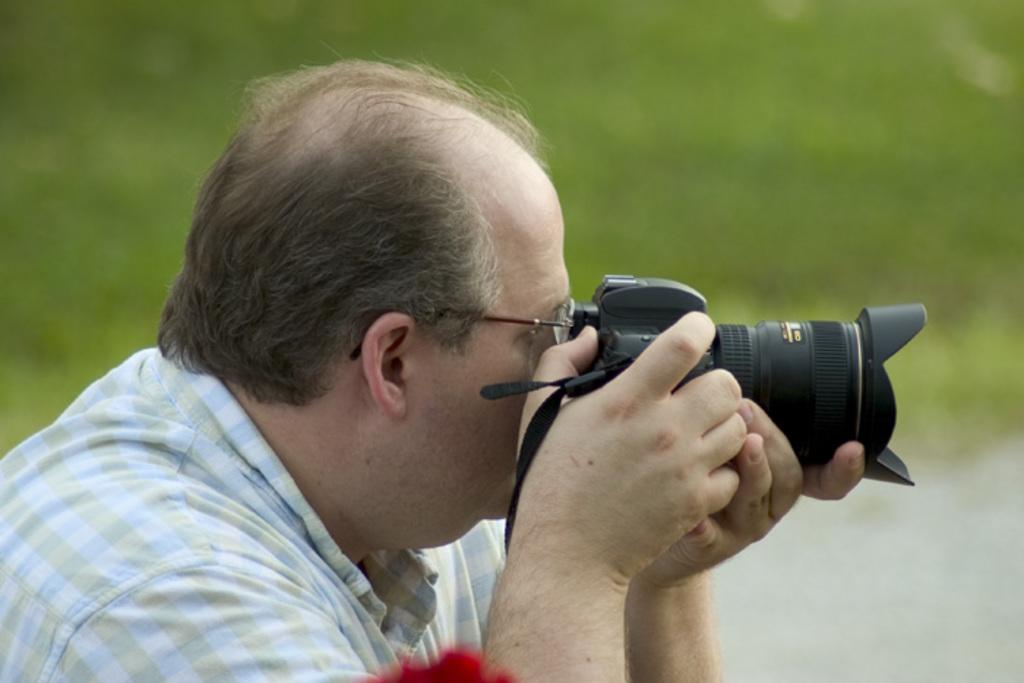What is the main subject of the image? There is a man in the image. What is the man holding in the image? The man is holding a camera. What type of roll can be seen in the image? There is no roll present in the image; it only features a man holding a camera. What scientific discovery is depicted in the image? There is no scientific discovery depicted in the image; it only features a man holding a camera. 